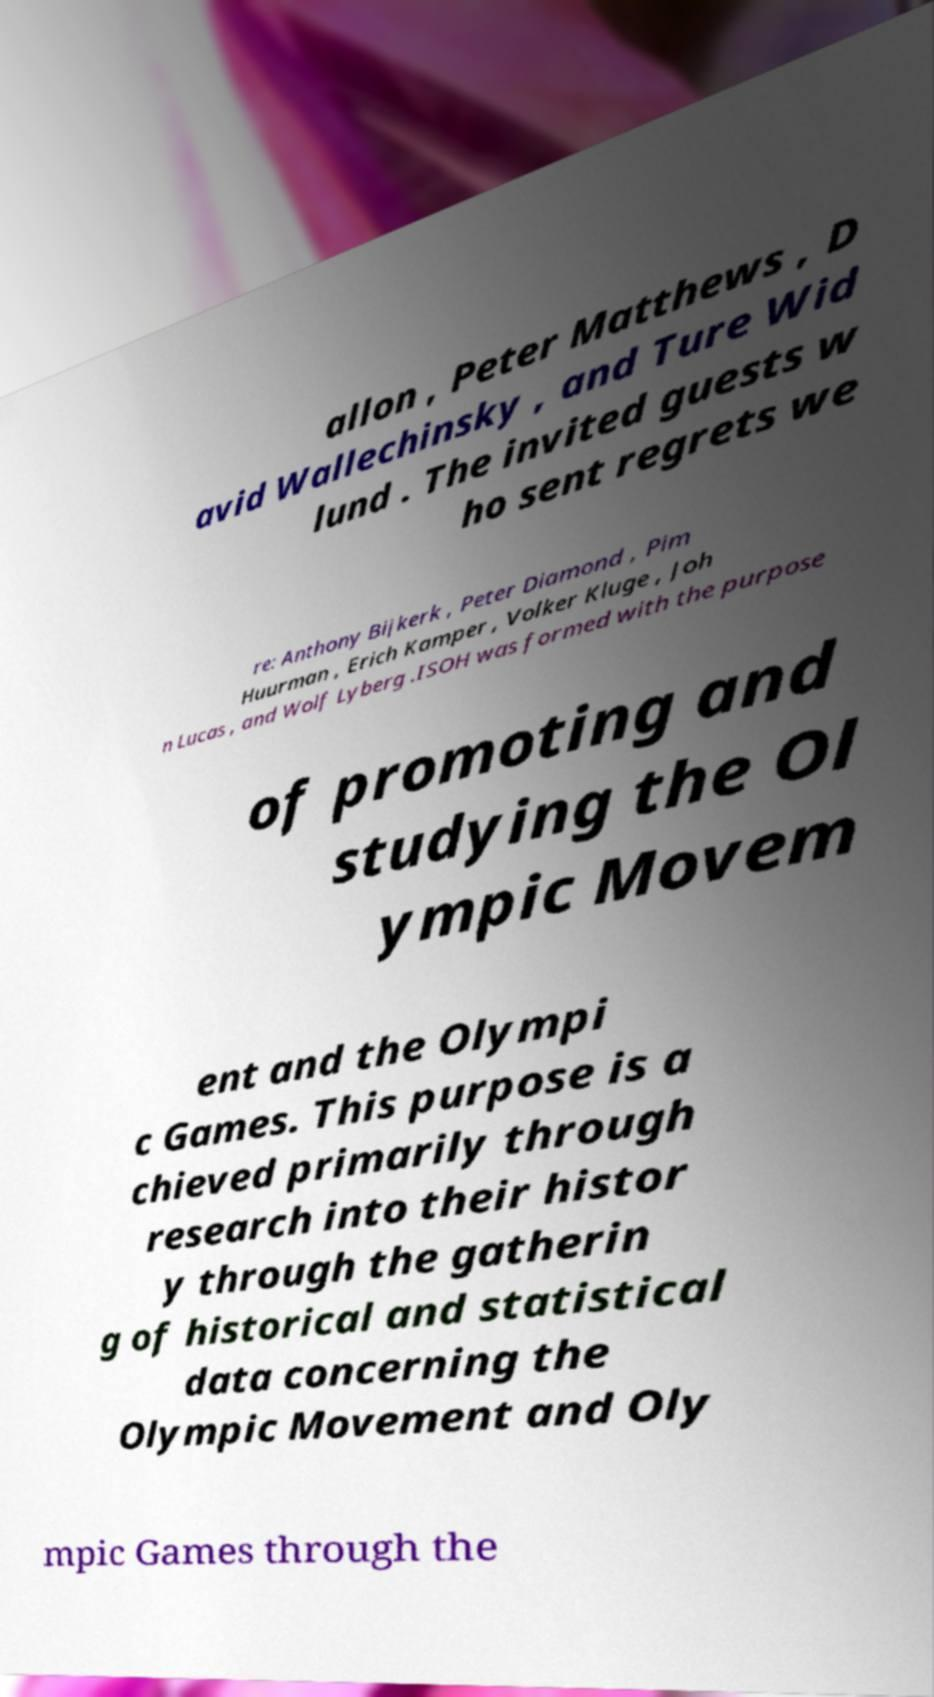Please read and relay the text visible in this image. What does it say? allon , Peter Matthews , D avid Wallechinsky , and Ture Wid lund . The invited guests w ho sent regrets we re: Anthony Bijkerk , Peter Diamond , Pim Huurman , Erich Kamper , Volker Kluge , Joh n Lucas , and Wolf Lyberg .ISOH was formed with the purpose of promoting and studying the Ol ympic Movem ent and the Olympi c Games. This purpose is a chieved primarily through research into their histor y through the gatherin g of historical and statistical data concerning the Olympic Movement and Oly mpic Games through the 